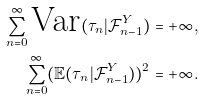Convert formula to latex. <formula><loc_0><loc_0><loc_500><loc_500>\sum ^ { \infty } _ { n = 0 } \text {Var} ( \tau _ { n } | \mathcal { F } ^ { Y } _ { n - 1 } ) & = + \infty , \\ \sum ^ { \infty } _ { n = 0 } ( \mathbb { E } ( \tau _ { n } | \mathcal { F } ^ { Y } _ { n - 1 } ) ) ^ { 2 } & = + \infty .</formula> 